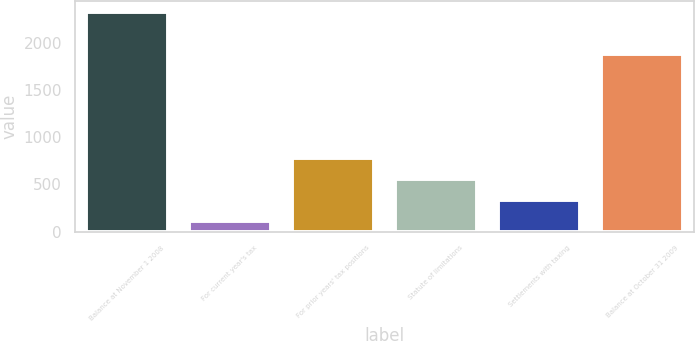Convert chart to OTSL. <chart><loc_0><loc_0><loc_500><loc_500><bar_chart><fcel>Balance at November 1 2008<fcel>For current year's tax<fcel>For prior years' tax positions<fcel>Statute of limitations<fcel>Settlements with taxing<fcel>Balance at October 31 2009<nl><fcel>2333<fcel>115<fcel>780.4<fcel>558.6<fcel>336.8<fcel>1888<nl></chart> 